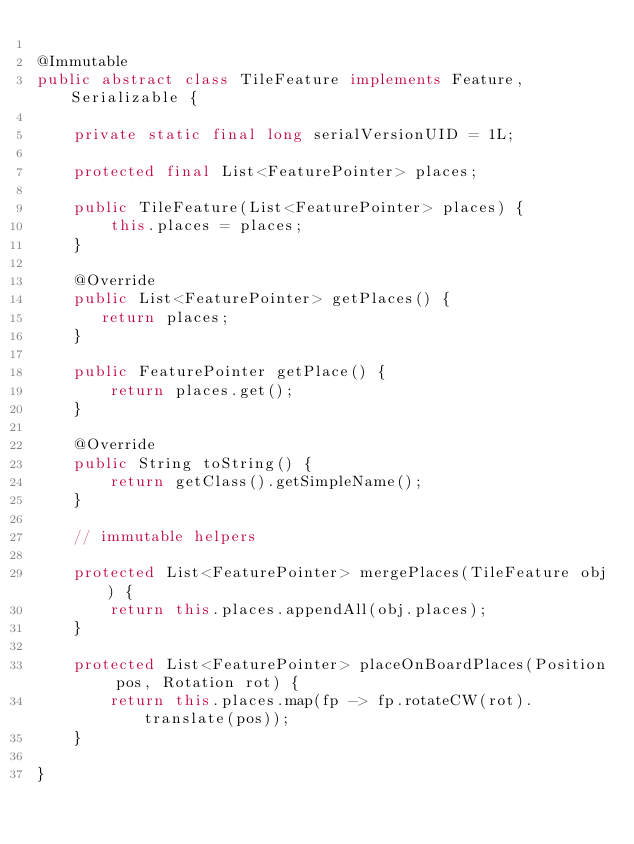<code> <loc_0><loc_0><loc_500><loc_500><_Java_>
@Immutable
public abstract class TileFeature implements Feature, Serializable {

    private static final long serialVersionUID = 1L;

    protected final List<FeaturePointer> places;

    public TileFeature(List<FeaturePointer> places) {
        this.places = places;
    }

    @Override
    public List<FeaturePointer> getPlaces() {
       return places;
    }

    public FeaturePointer getPlace() {
        return places.get();
    }

    @Override
    public String toString() {
        return getClass().getSimpleName();
    }

    // immutable helpers

    protected List<FeaturePointer> mergePlaces(TileFeature obj) {
        return this.places.appendAll(obj.places);
    }

    protected List<FeaturePointer> placeOnBoardPlaces(Position pos, Rotation rot) {
        return this.places.map(fp -> fp.rotateCW(rot).translate(pos));
    }

}
</code> 